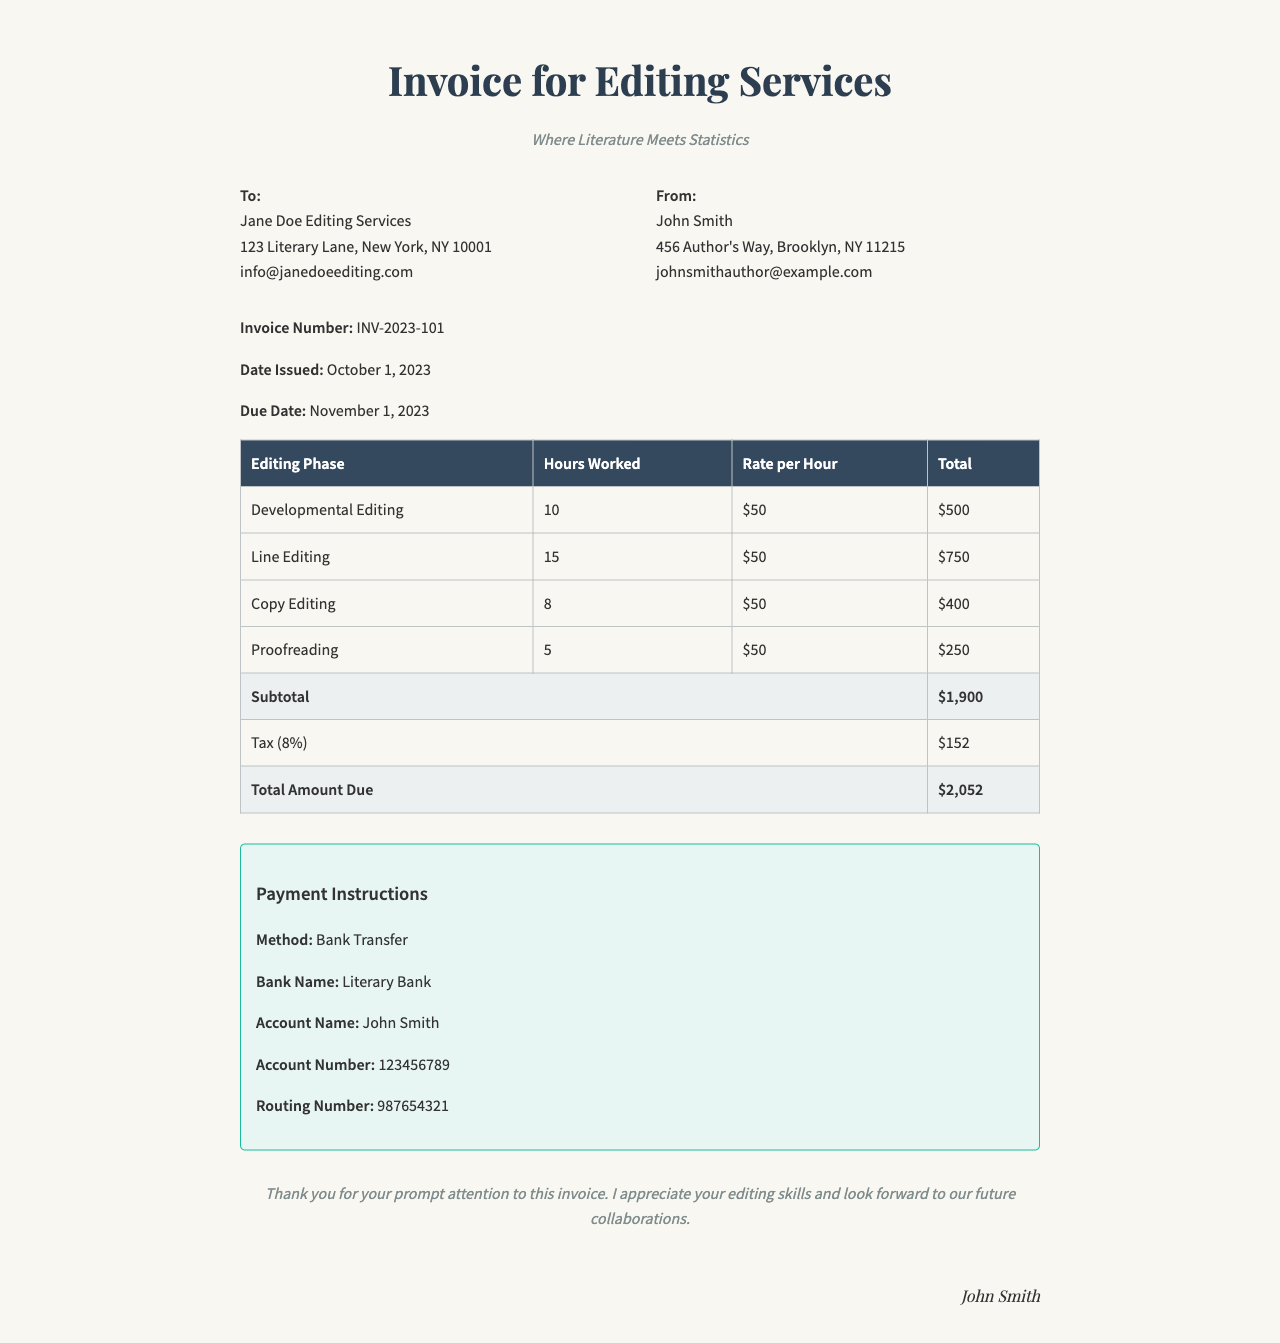What is the invoice number? The invoice number is a specific identifier for the invoice, stated clearly in the document.
Answer: INV-2023-101 Who is the sender of the invoice? The sender of the invoice is the person or entity who issued the invoice, mentioned specifically in the document.
Answer: John Smith What is the total amount due? The total amount due is the final figure that the recipient needs to pay, calculated at the end of the invoice.
Answer: $2,052 How many hours were spent on Line Editing? This question focuses on the specific hours listed for the Line Editing phase in the table.
Answer: 15 What is the tax percentage applied in the invoice? The tax percentage is calculated based on the subtotal and is indicated in the invoice document.
Answer: 8% Which editing phase had the highest total cost? This question requires comparison of the total values in each editing phase to determine which one is highest.
Answer: Line Editing What is the due date for the invoice? The due date is important for payment planning and is explicitly mentioned in the invoice.
Answer: November 1, 2023 What method of payment is specified in the invoice? This refers to the payment instructions section where the method for payment is stated.
Answer: Bank Transfer What is the subtotal before tax in the invoice? The subtotal is before any tax is added and is provided in a specific row in the document.
Answer: $1,900 